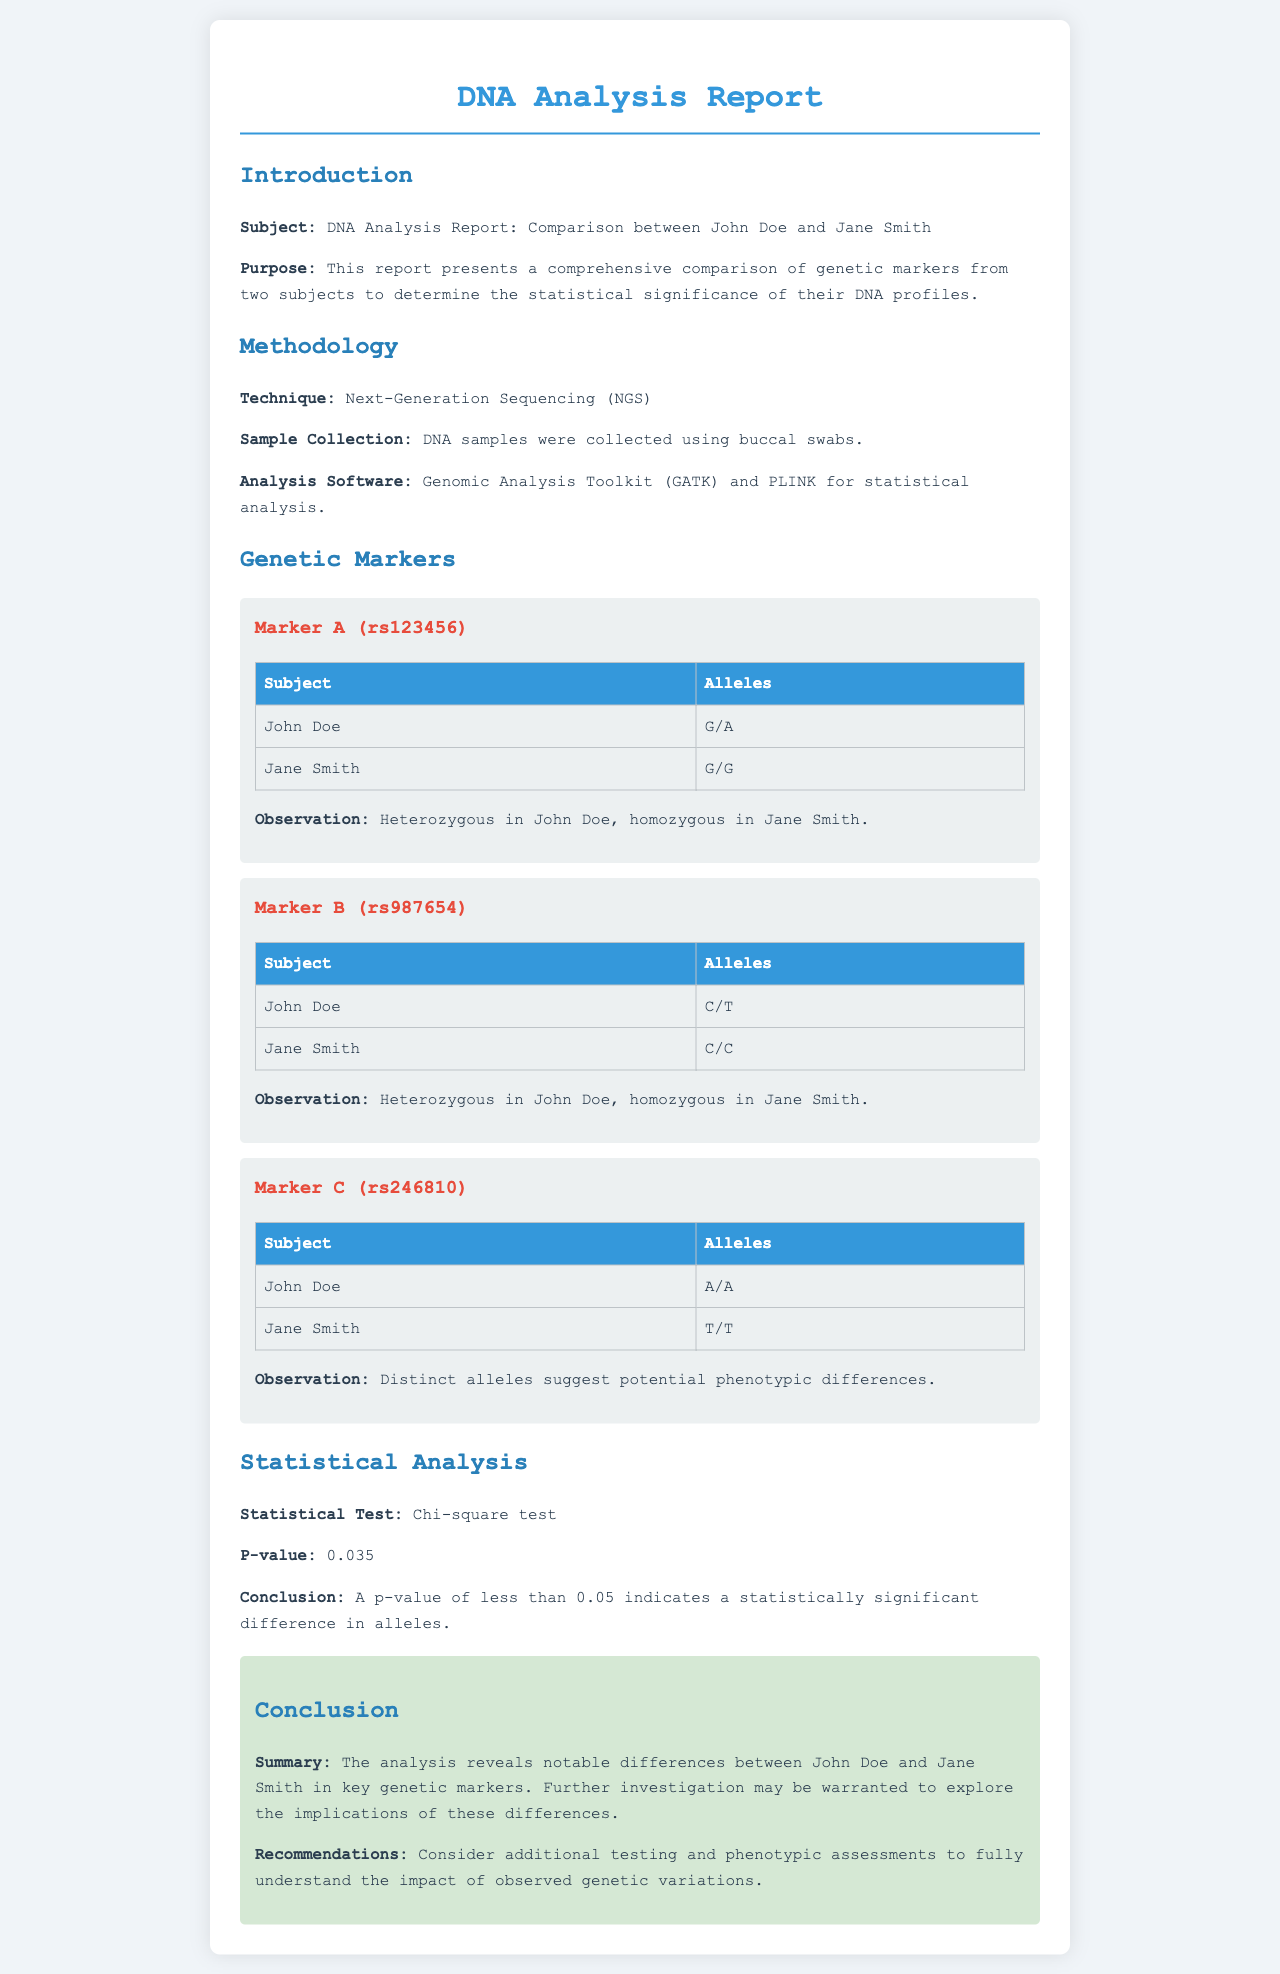What is the subject of the report? The subject of the report is the comparison between John Doe and Jane Smith's DNA profiles.
Answer: Comparison between John Doe and Jane Smith What technique was used for analysis? The document specifies that Next-Generation Sequencing (NGS) was used as the technique for analysis.
Answer: Next-Generation Sequencing (NGS) What is the p-value reported in the statistical analysis? The p-value is provided to indicate the statistical significance of the allele differences, which is stated as 0.035.
Answer: 0.035 How many genetic markers are assessed in the report? There are three specific genetic markers (A, B, and C) assessed in the report, each with its own observation.
Answer: Three Which subject is heterozygous at Marker A? The report states that John Doe is heterozygous at Marker A (rs123456).
Answer: John Doe What does a p-value less than 0.05 indicate? It indicates a statistically significant difference in alleles between the subjects being compared.
Answer: Statistically significant difference What is the conclusion regarding the genetic markers? The conclusion states that there are notable differences between the two subjects in key genetic markers.
Answer: Notable differences What recommendation is made for further research? The report recommends considering additional testing and phenotypic assessments to understand the impact of the genetic variations.
Answer: Additional testing and phenotypic assessments 